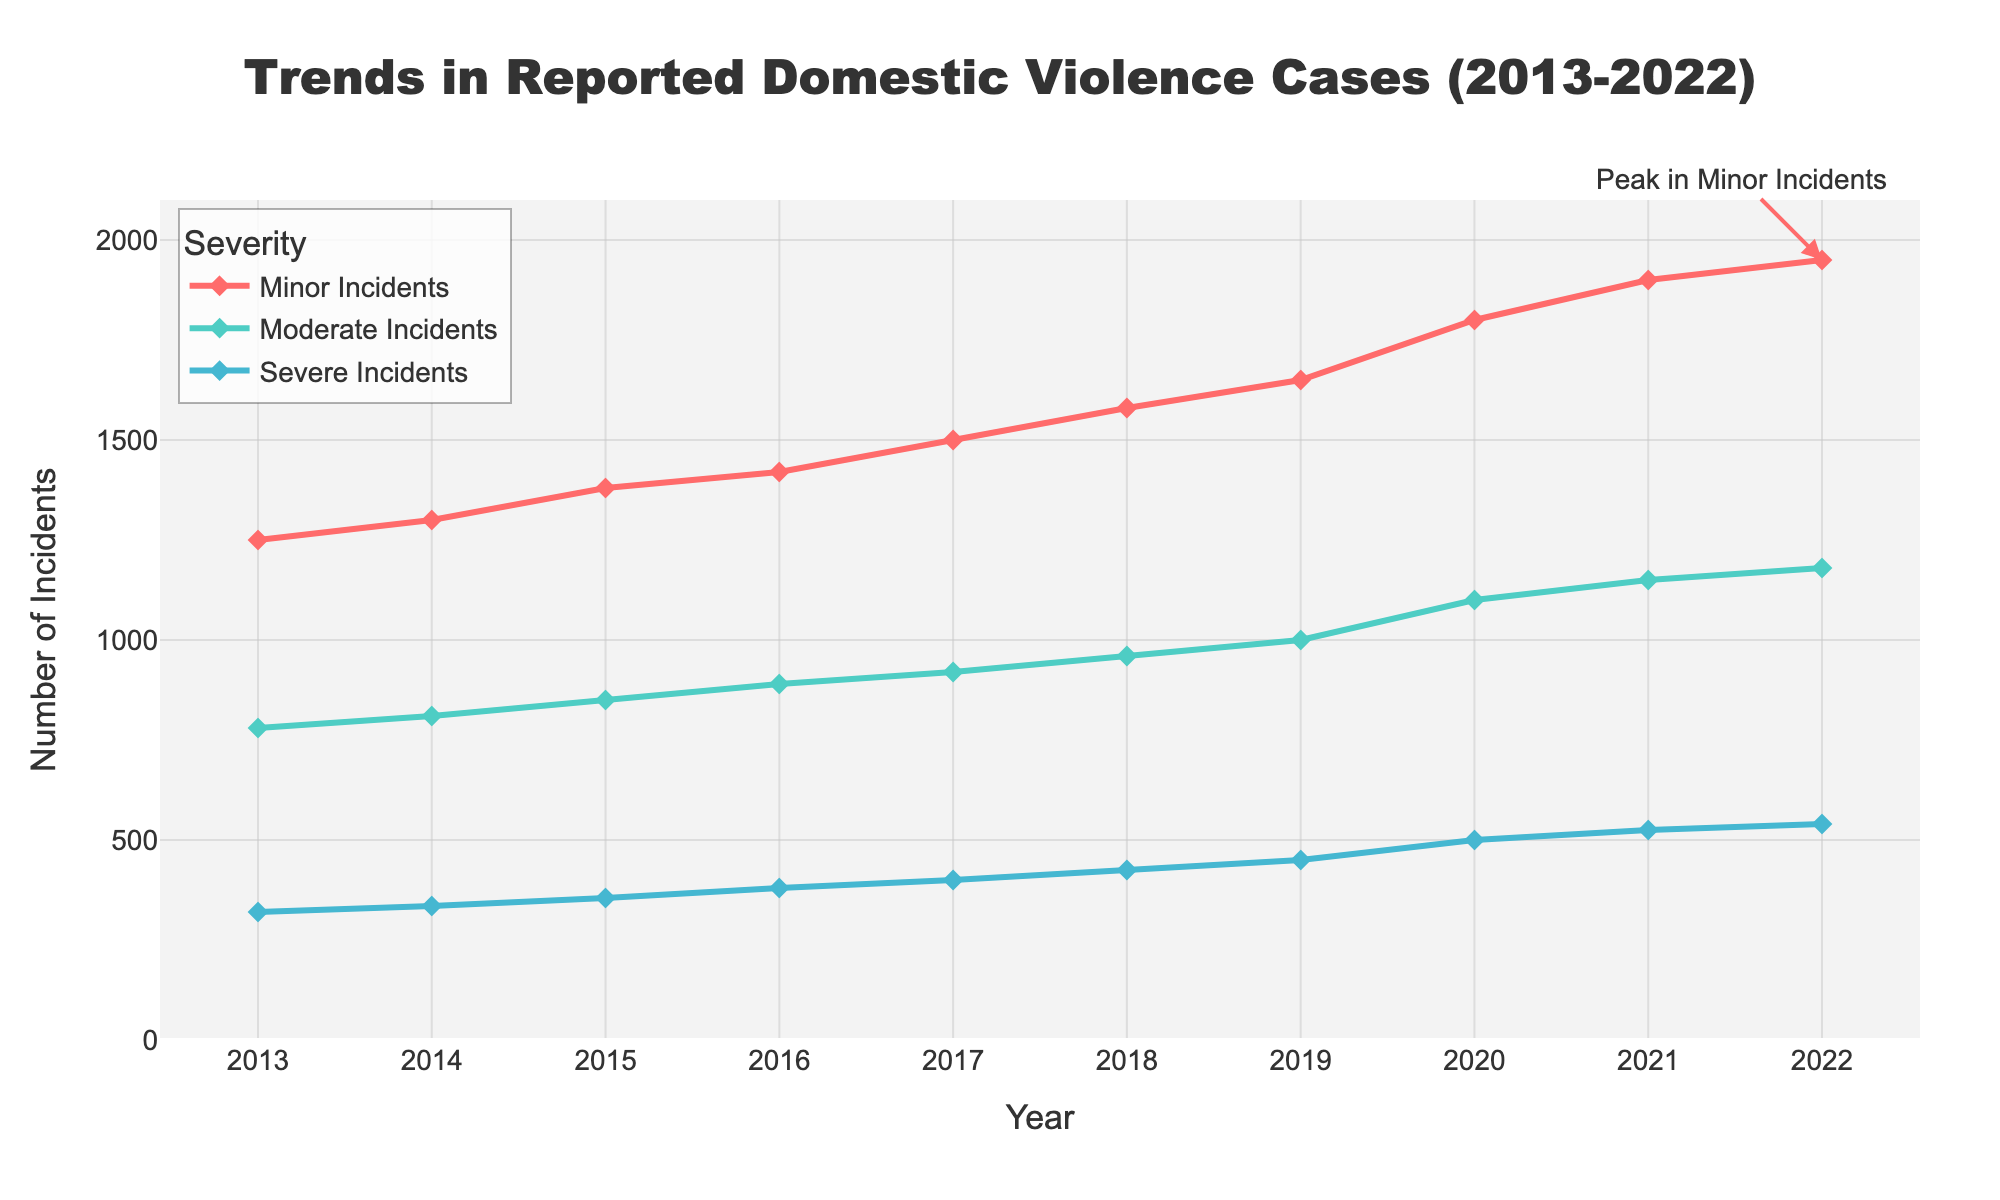What's the highest number of incidents reported for each category over the decade? The highest number of incidents for each category can be seen by looking at the peaks on the graph for Minor, Moderate, and Severe Incidents. For Minor Incidents, the peak is in 2022 with 1950 incidents. For Moderate Incidents, the peak is in 2022 with 1180 incidents. For Severe Incidents, the peak is also in 2022 with 540 incidents.
Answer: 1950, 1180, 540 Compare the trends of Minor and Severe Incidents from 2013 to 2022. Which one increased more? To compare the trends, we need to look at the difference in incidents from 2013 to 2022 for both categories. Minor Incidents increased from 1250 to 1950, which is an increase of 700. Severe Incidents increased from 320 to 540, which is an increase of 220. Therefore, Minor Incidents increased more.
Answer: Minor Incidents What is the average number of Moderate Incidents over the decade? To find the average number of Moderate Incidents, sum the values for each year and then divide by the number of years. The sum is (780 + 810 + 850 + 890 + 920 + 960 + 1000 + 1100 + 1150 + 1180) = 9640. Dividing by the number of years (10) gives 964.
Answer: 964 Which year saw the greatest relative increase in the number of Minor Incidents compared to the previous year? To find the year with the greatest relative increase, calculate the year-over-year changes. From 2018 to 2019, Minor Incidents increased from 1580 to 1650, a change of 70. From 2019 to 2020, the change was from 1650 to 1800, a change of 150. Therefore, 2020 saw the greatest relative increase.
Answer: 2020 By how much did the number of Severe Incidents increase from 2013 to 2022? Subtract the number of Severe Incidents in 2013 from that in 2022. The increase is 540 - 320 = 220.
Answer: 220 